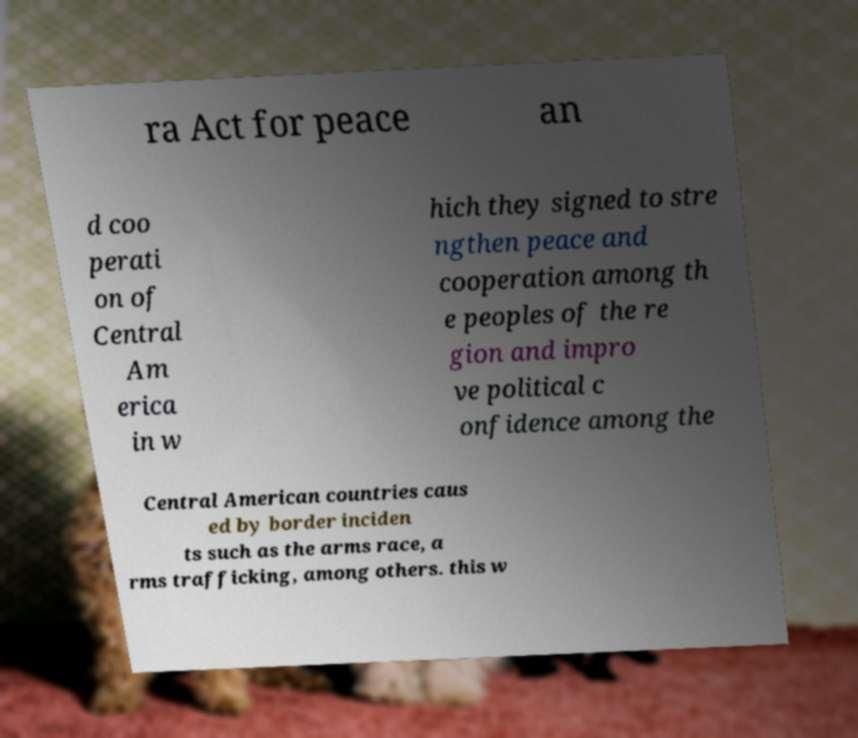Could you extract and type out the text from this image? ra Act for peace an d coo perati on of Central Am erica in w hich they signed to stre ngthen peace and cooperation among th e peoples of the re gion and impro ve political c onfidence among the Central American countries caus ed by border inciden ts such as the arms race, a rms trafficking, among others. this w 